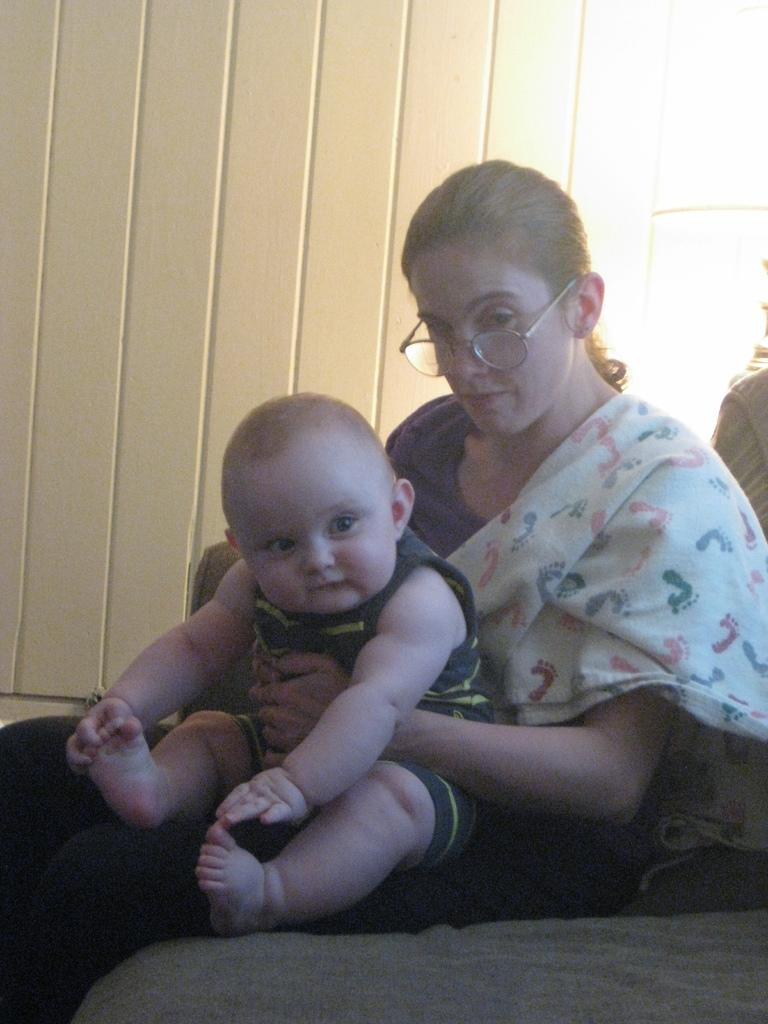Who is the main subject in the foreground of the image? There is a woman in the foreground of the image. What is the woman sitting on? The woman is sitting on a grey surface. What is the woman doing with her hands? The woman is holding a baby on her laps. What can be seen in the background of the image? There is a white wall in the background of the image. What type of machine is being used by the woman in the image? There is no machine present in the image; the woman is holding a baby on her laps. What part of the woman's body is visible in the image? The woman's entire body is not visible in the image, but her arms and upper body are visible as she holds the baby. 